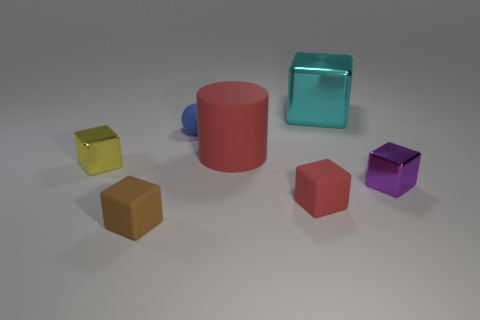There is a block to the right of the cyan shiny block; is its size the same as the tiny brown thing?
Your answer should be compact. Yes. There is a big cyan metal thing; what shape is it?
Your answer should be very brief. Cube. The other rubber thing that is the same color as the big matte object is what size?
Provide a succinct answer. Small. Does the small cube that is left of the brown rubber object have the same material as the tiny brown cube?
Make the answer very short. No. Is there a large rubber thing of the same color as the large cube?
Provide a succinct answer. No. There is a red thing that is in front of the yellow object; does it have the same shape as the tiny metal thing on the right side of the blue rubber ball?
Give a very brief answer. Yes. Are there any other red cylinders made of the same material as the cylinder?
Make the answer very short. No. How many red objects are either tiny objects or tiny spheres?
Your response must be concise. 1. What is the size of the block that is in front of the big metallic cube and to the right of the red block?
Offer a terse response. Small. Are there more tiny red cubes that are left of the brown matte block than small brown rubber objects?
Offer a very short reply. No. 